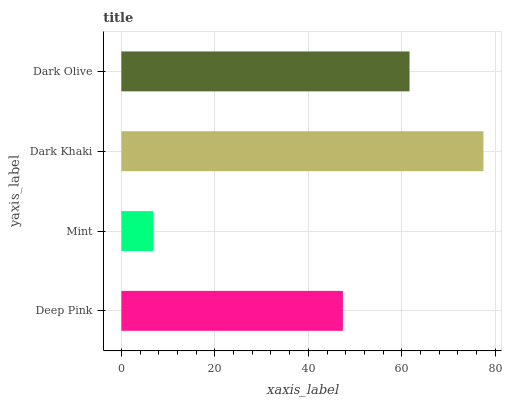Is Mint the minimum?
Answer yes or no. Yes. Is Dark Khaki the maximum?
Answer yes or no. Yes. Is Dark Khaki the minimum?
Answer yes or no. No. Is Mint the maximum?
Answer yes or no. No. Is Dark Khaki greater than Mint?
Answer yes or no. Yes. Is Mint less than Dark Khaki?
Answer yes or no. Yes. Is Mint greater than Dark Khaki?
Answer yes or no. No. Is Dark Khaki less than Mint?
Answer yes or no. No. Is Dark Olive the high median?
Answer yes or no. Yes. Is Deep Pink the low median?
Answer yes or no. Yes. Is Mint the high median?
Answer yes or no. No. Is Mint the low median?
Answer yes or no. No. 